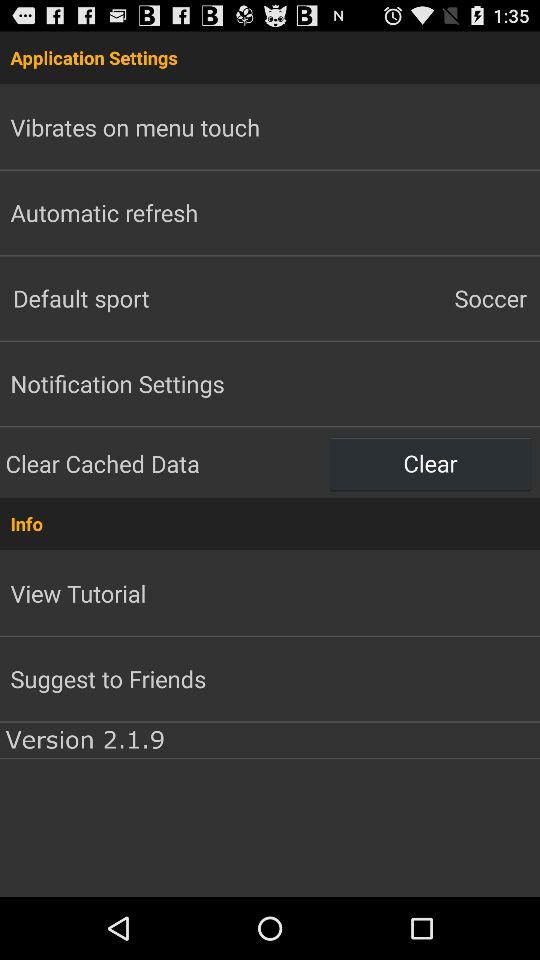What is the version of this app? The version of this app is 2.1.9. 